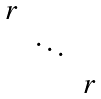<formula> <loc_0><loc_0><loc_500><loc_500>\begin{matrix} r & & \\ & \ddots & \\ & & r \end{matrix}</formula> 